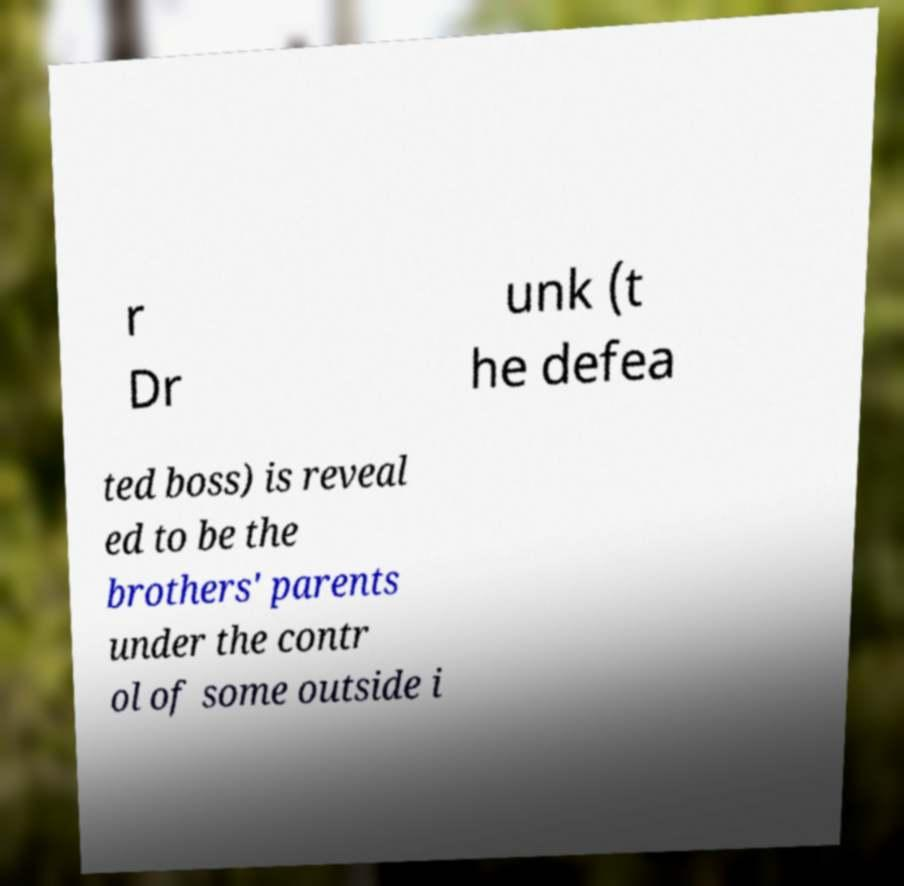Could you extract and type out the text from this image? r Dr unk (t he defea ted boss) is reveal ed to be the brothers' parents under the contr ol of some outside i 